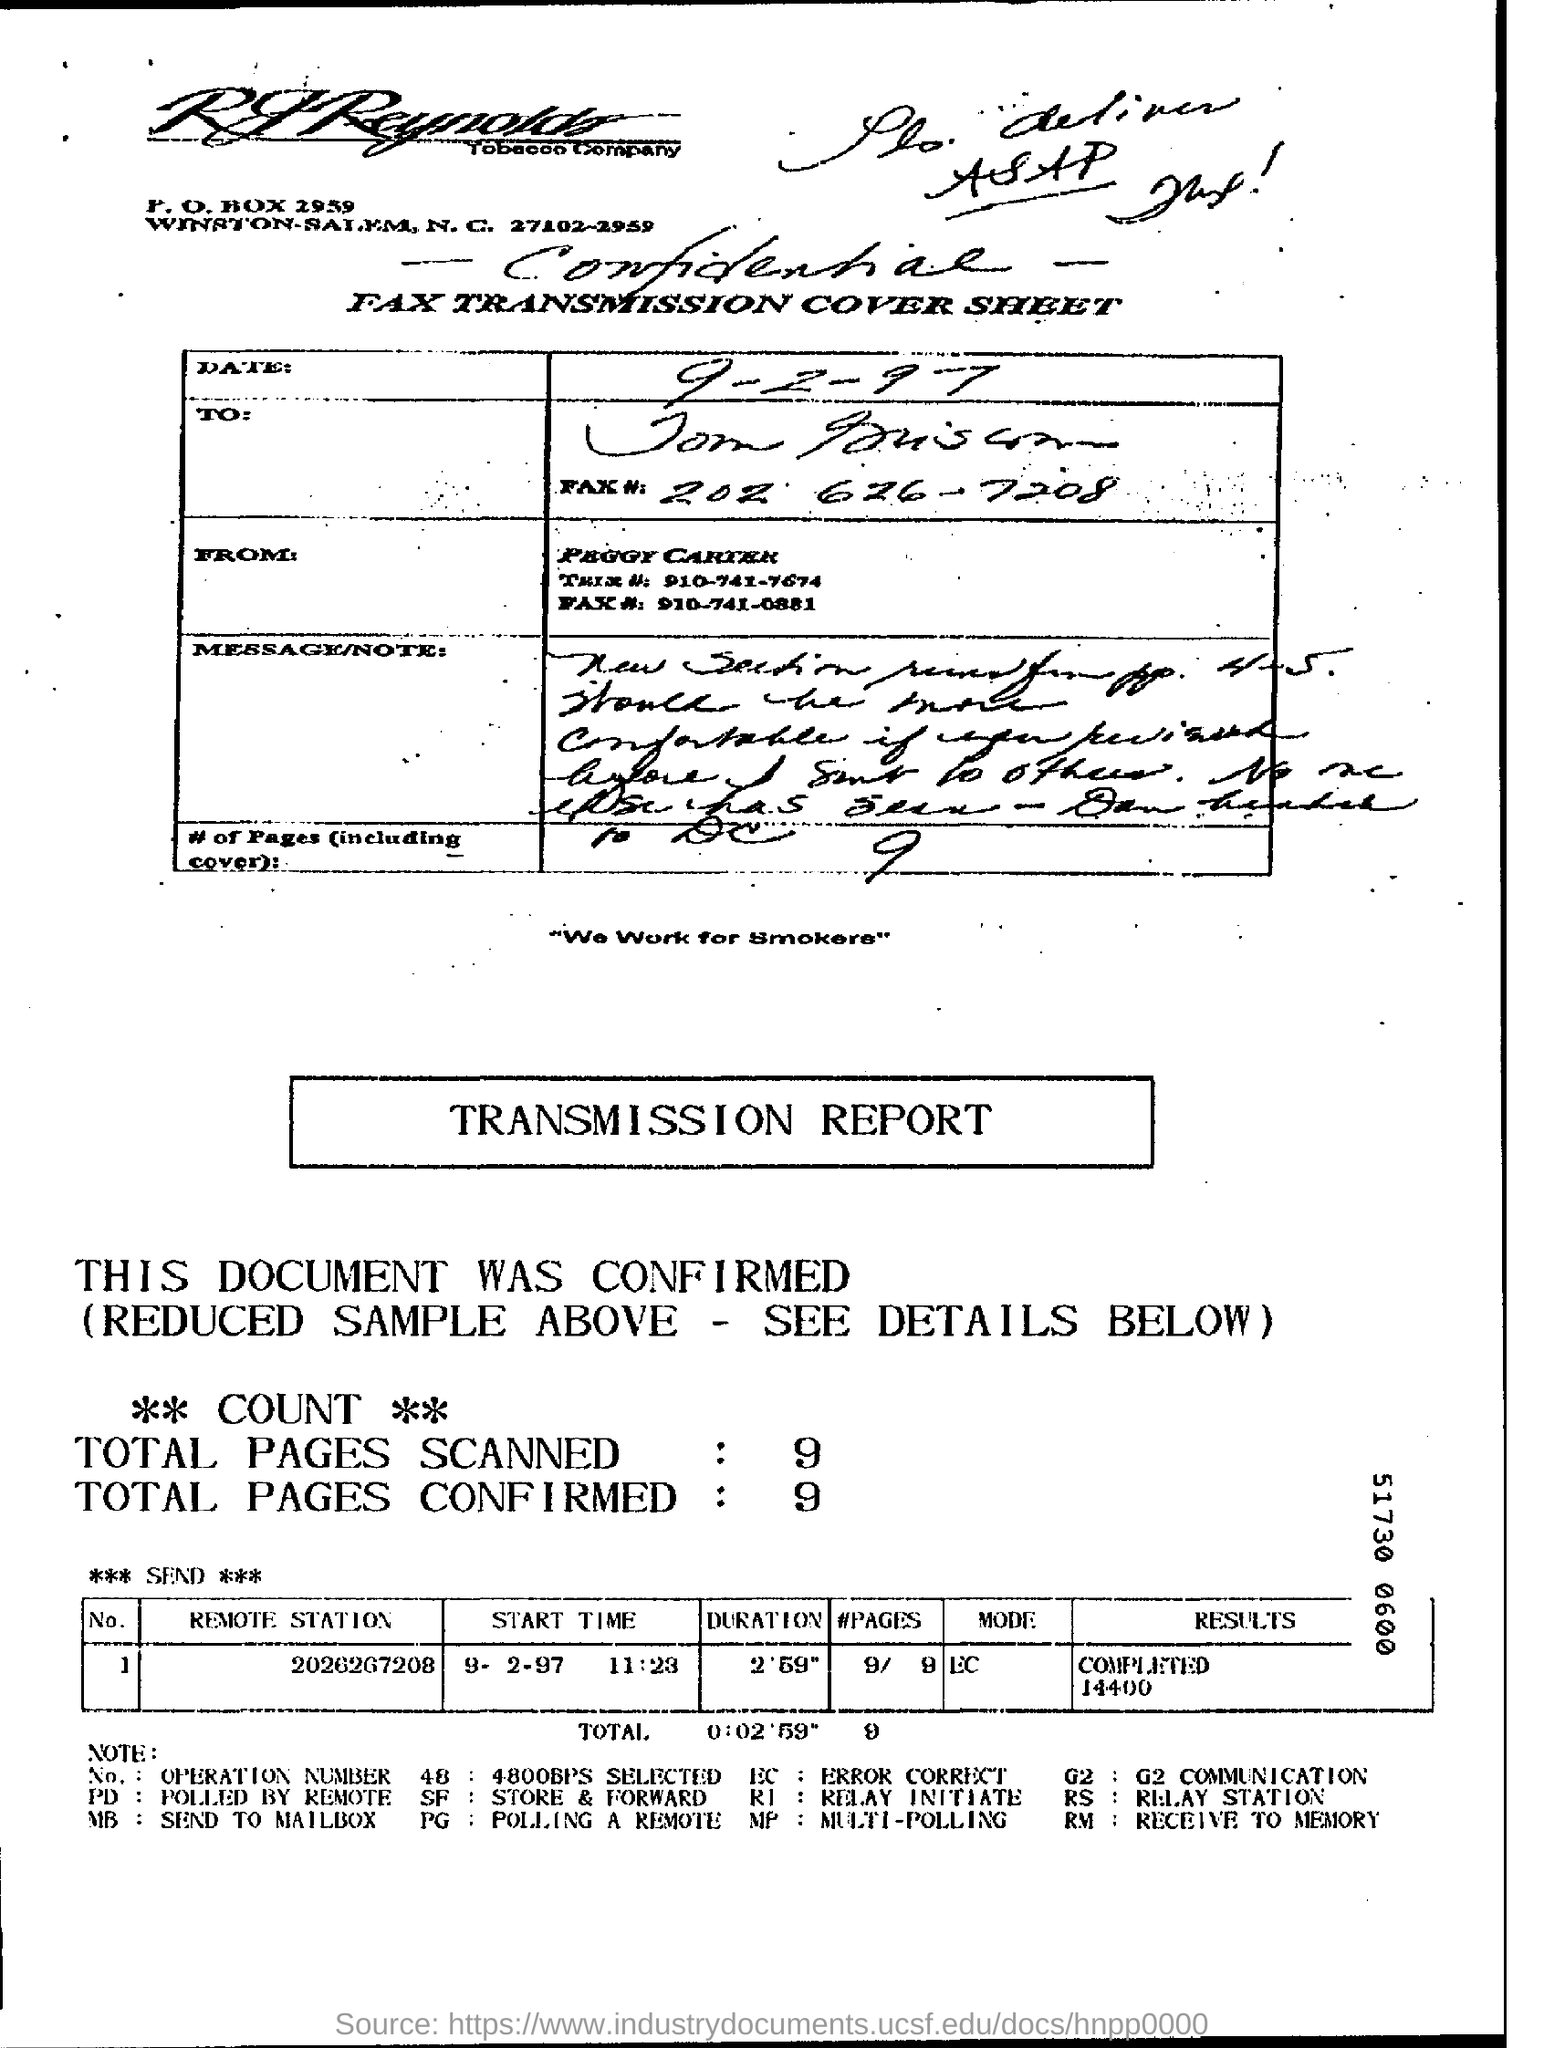Indicate a few pertinent items in this graphic. The process was completed in 2 minutes and 59 seconds. Nine pages were scanned in total. 